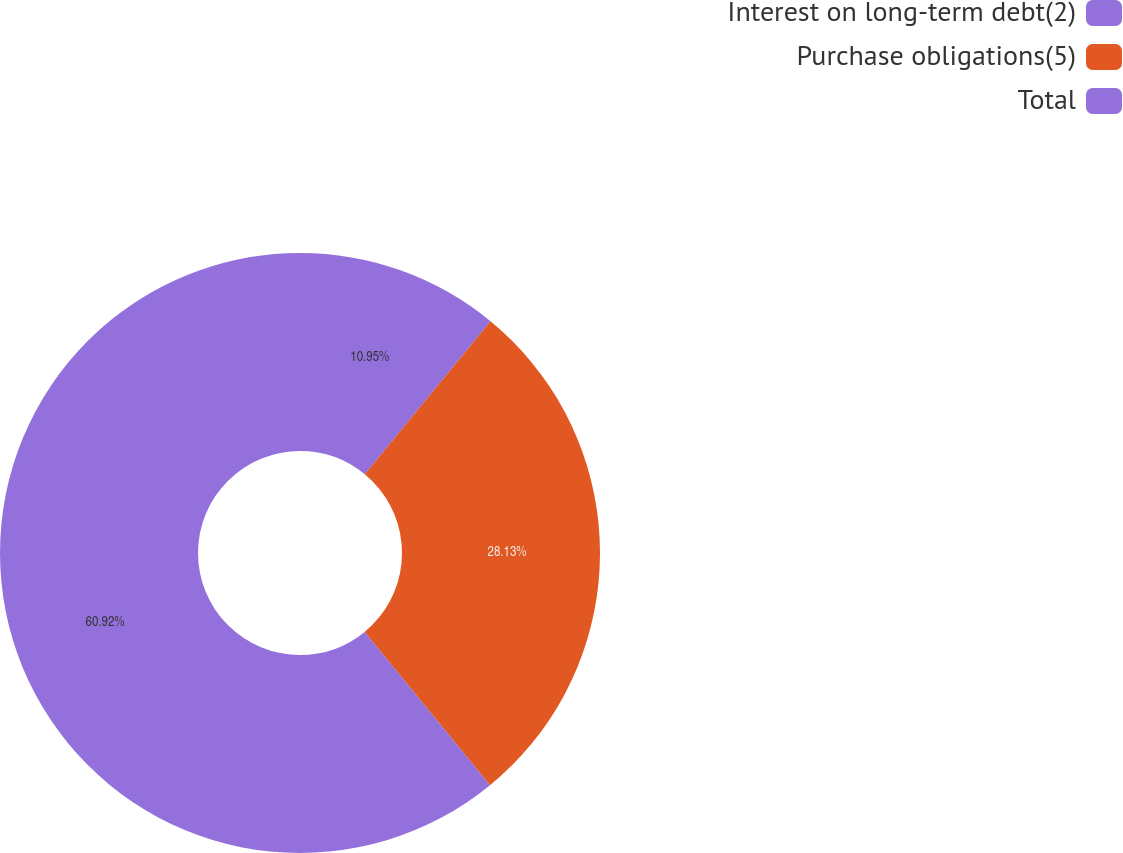<chart> <loc_0><loc_0><loc_500><loc_500><pie_chart><fcel>Interest on long-term debt(2)<fcel>Purchase obligations(5)<fcel>Total<nl><fcel>10.95%<fcel>28.13%<fcel>60.91%<nl></chart> 